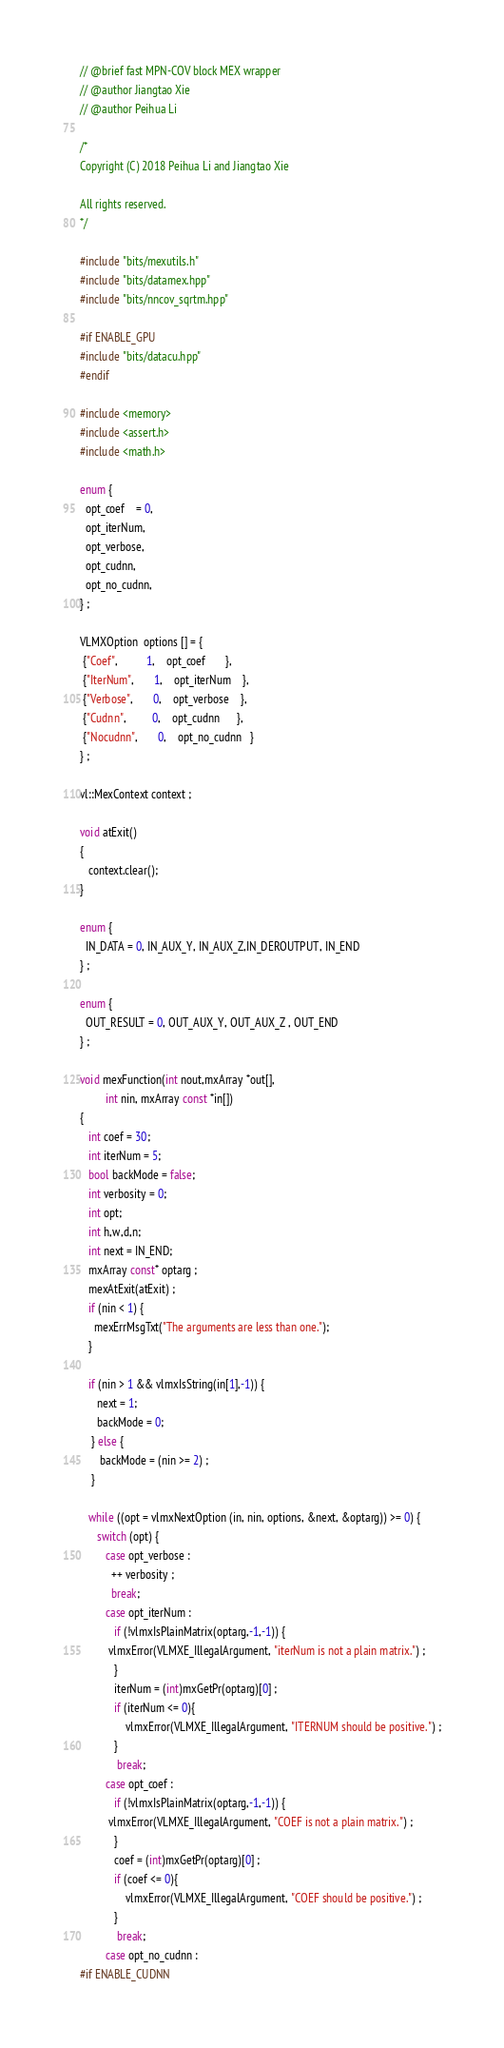Convert code to text. <code><loc_0><loc_0><loc_500><loc_500><_Cuda_>// @brief fast MPN-COV block MEX wrapper
// @author Jiangtao Xie
// @author Peihua Li

/*
Copyright (C) 2018 Peihua Li and Jiangtao Xie

All rights reserved.
*/

#include "bits/mexutils.h"
#include "bits/datamex.hpp"
#include "bits/nncov_sqrtm.hpp"

#if ENABLE_GPU
#include "bits/datacu.hpp"
#endif

#include <memory>
#include <assert.h>
#include <math.h>

enum {
  opt_coef    = 0,
  opt_iterNum,
  opt_verbose,
  opt_cudnn,
  opt_no_cudnn,
} ;

VLMXOption  options [] = {
 {"Coef",          1,    opt_coef       },
 {"IterNum",       1,    opt_iterNum    },
 {"Verbose",       0,    opt_verbose    },
 {"Cudnn",         0,    opt_cudnn      },
 {"Nocudnn",       0,    opt_no_cudnn   }
} ;

vl::MexContext context ;

void atExit()
{
   context.clear();
}

enum {
  IN_DATA = 0, IN_AUX_Y, IN_AUX_Z,IN_DEROUTPUT, IN_END
} ;

enum {
  OUT_RESULT = 0, OUT_AUX_Y, OUT_AUX_Z , OUT_END
} ;

void mexFunction(int nout,mxArray *out[],
         int nin, mxArray const *in[])
{
   int coef = 30;
   int iterNum = 5;
   bool backMode = false;
   int verbosity = 0;
   int opt;
   int h,w,d,n;
   int next = IN_END;
   mxArray const* optarg ;
   mexAtExit(atExit) ;
   if (nin < 1) {
     mexErrMsgTxt("The arguments are less than one.");
   }
   
   if (nin > 1 && vlmxIsString(in[1],-1)) {
      next = 1;
      backMode = 0;
    } else {
       backMode = (nin >= 2) ;
    }

   while ((opt = vlmxNextOption (in, nin, options, &next, &optarg)) >= 0) {
      switch (opt) {
         case opt_verbose :
           ++ verbosity ;
           break;
         case opt_iterNum :
            if (!vlmxIsPlainMatrix(optarg,-1,-1)) {
          vlmxError(VLMXE_IllegalArgument, "iterNum is not a plain matrix.") ;
            }
            iterNum = (int)mxGetPr(optarg)[0] ;
			if (iterNum <= 0){
				vlmxError(VLMXE_IllegalArgument, "ITERNUM should be positive.") ;
			}
             break;
		 case opt_coef :
            if (!vlmxIsPlainMatrix(optarg,-1,-1)) {
          vlmxError(VLMXE_IllegalArgument, "COEF is not a plain matrix.") ;
            }
            coef = (int)mxGetPr(optarg)[0] ;
			if (coef <= 0){
				vlmxError(VLMXE_IllegalArgument, "COEF should be positive.") ;
			}
             break;
         case opt_no_cudnn :
#if ENABLE_CUDNN</code> 